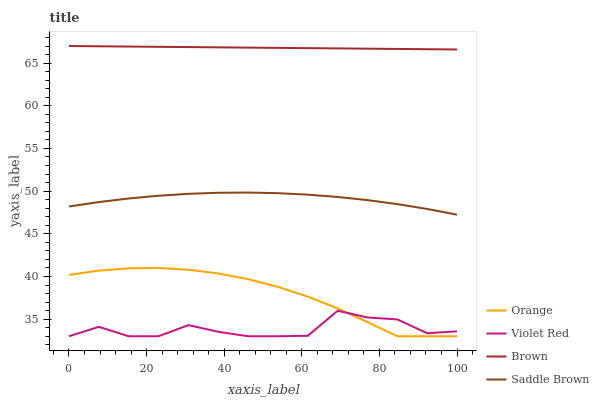Does Violet Red have the minimum area under the curve?
Answer yes or no. Yes. Does Brown have the maximum area under the curve?
Answer yes or no. Yes. Does Brown have the minimum area under the curve?
Answer yes or no. No. Does Violet Red have the maximum area under the curve?
Answer yes or no. No. Is Brown the smoothest?
Answer yes or no. Yes. Is Violet Red the roughest?
Answer yes or no. Yes. Is Violet Red the smoothest?
Answer yes or no. No. Is Brown the roughest?
Answer yes or no. No. Does Brown have the lowest value?
Answer yes or no. No. Does Violet Red have the highest value?
Answer yes or no. No. Is Orange less than Brown?
Answer yes or no. Yes. Is Brown greater than Violet Red?
Answer yes or no. Yes. Does Orange intersect Brown?
Answer yes or no. No. 